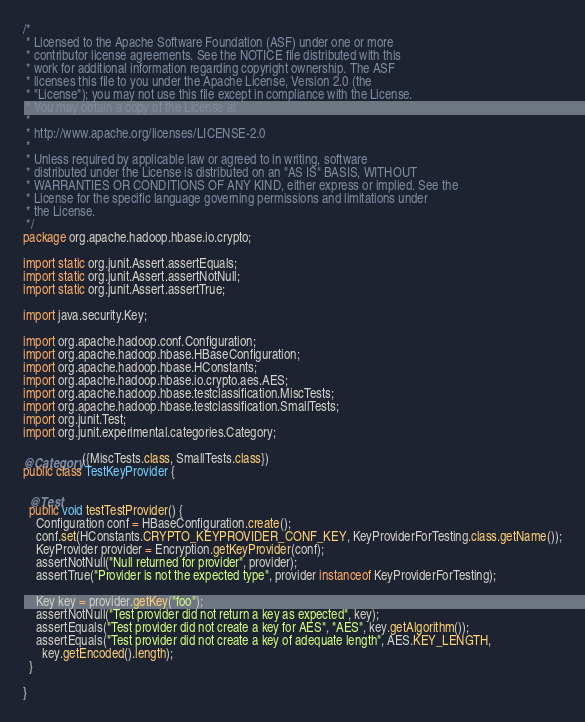Convert code to text. <code><loc_0><loc_0><loc_500><loc_500><_Java_>/*
 * Licensed to the Apache Software Foundation (ASF) under one or more
 * contributor license agreements. See the NOTICE file distributed with this
 * work for additional information regarding copyright ownership. The ASF
 * licenses this file to you under the Apache License, Version 2.0 (the
 * "License"); you may not use this file except in compliance with the License.
 * You may obtain a copy of the License at
 *
 * http://www.apache.org/licenses/LICENSE-2.0
 *
 * Unless required by applicable law or agreed to in writing, software
 * distributed under the License is distributed on an "AS IS" BASIS, WITHOUT
 * WARRANTIES OR CONDITIONS OF ANY KIND, either express or implied. See the
 * License for the specific language governing permissions and limitations under
 * the License.
 */
package org.apache.hadoop.hbase.io.crypto;

import static org.junit.Assert.assertEquals;
import static org.junit.Assert.assertNotNull;
import static org.junit.Assert.assertTrue;

import java.security.Key;

import org.apache.hadoop.conf.Configuration;
import org.apache.hadoop.hbase.HBaseConfiguration;
import org.apache.hadoop.hbase.HConstants;
import org.apache.hadoop.hbase.io.crypto.aes.AES;
import org.apache.hadoop.hbase.testclassification.MiscTests;
import org.apache.hadoop.hbase.testclassification.SmallTests;
import org.junit.Test;
import org.junit.experimental.categories.Category;

@Category({MiscTests.class, SmallTests.class})
public class TestKeyProvider {

  @Test
  public void testTestProvider() {
    Configuration conf = HBaseConfiguration.create();
    conf.set(HConstants.CRYPTO_KEYPROVIDER_CONF_KEY, KeyProviderForTesting.class.getName());
    KeyProvider provider = Encryption.getKeyProvider(conf);
    assertNotNull("Null returned for provider", provider);
    assertTrue("Provider is not the expected type", provider instanceof KeyProviderForTesting);

    Key key = provider.getKey("foo");
    assertNotNull("Test provider did not return a key as expected", key);
    assertEquals("Test provider did not create a key for AES", "AES", key.getAlgorithm());
    assertEquals("Test provider did not create a key of adequate length", AES.KEY_LENGTH,
      key.getEncoded().length);
  }

}
</code> 